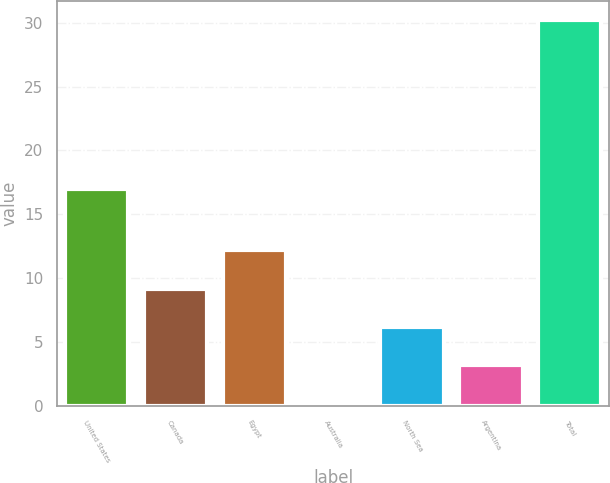Convert chart to OTSL. <chart><loc_0><loc_0><loc_500><loc_500><bar_chart><fcel>United States<fcel>Canada<fcel>Egypt<fcel>Australia<fcel>North Sea<fcel>Argentina<fcel>Total<nl><fcel>17<fcel>9.2<fcel>12.2<fcel>0.2<fcel>6.2<fcel>3.2<fcel>30.2<nl></chart> 